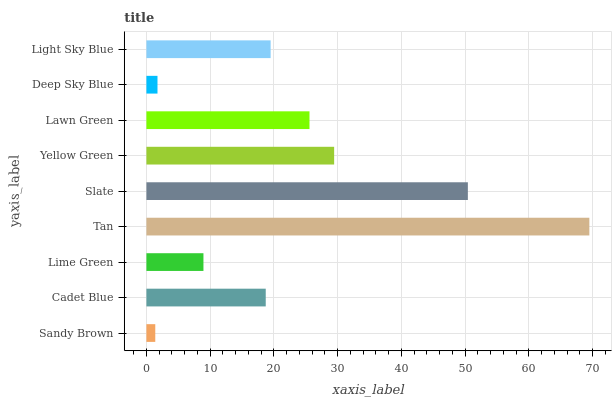Is Sandy Brown the minimum?
Answer yes or no. Yes. Is Tan the maximum?
Answer yes or no. Yes. Is Cadet Blue the minimum?
Answer yes or no. No. Is Cadet Blue the maximum?
Answer yes or no. No. Is Cadet Blue greater than Sandy Brown?
Answer yes or no. Yes. Is Sandy Brown less than Cadet Blue?
Answer yes or no. Yes. Is Sandy Brown greater than Cadet Blue?
Answer yes or no. No. Is Cadet Blue less than Sandy Brown?
Answer yes or no. No. Is Light Sky Blue the high median?
Answer yes or no. Yes. Is Light Sky Blue the low median?
Answer yes or no. Yes. Is Lawn Green the high median?
Answer yes or no. No. Is Deep Sky Blue the low median?
Answer yes or no. No. 